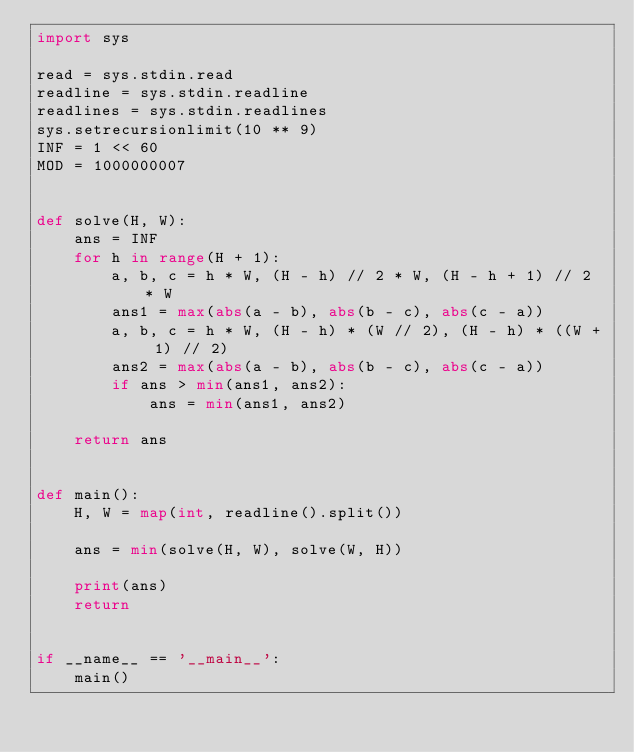<code> <loc_0><loc_0><loc_500><loc_500><_Python_>import sys

read = sys.stdin.read
readline = sys.stdin.readline
readlines = sys.stdin.readlines
sys.setrecursionlimit(10 ** 9)
INF = 1 << 60
MOD = 1000000007


def solve(H, W):
    ans = INF
    for h in range(H + 1):
        a, b, c = h * W, (H - h) // 2 * W, (H - h + 1) // 2 * W
        ans1 = max(abs(a - b), abs(b - c), abs(c - a))
        a, b, c = h * W, (H - h) * (W // 2), (H - h) * ((W + 1) // 2)
        ans2 = max(abs(a - b), abs(b - c), abs(c - a))
        if ans > min(ans1, ans2):
            ans = min(ans1, ans2)

    return ans


def main():
    H, W = map(int, readline().split())

    ans = min(solve(H, W), solve(W, H))

    print(ans)
    return


if __name__ == '__main__':
    main()
</code> 